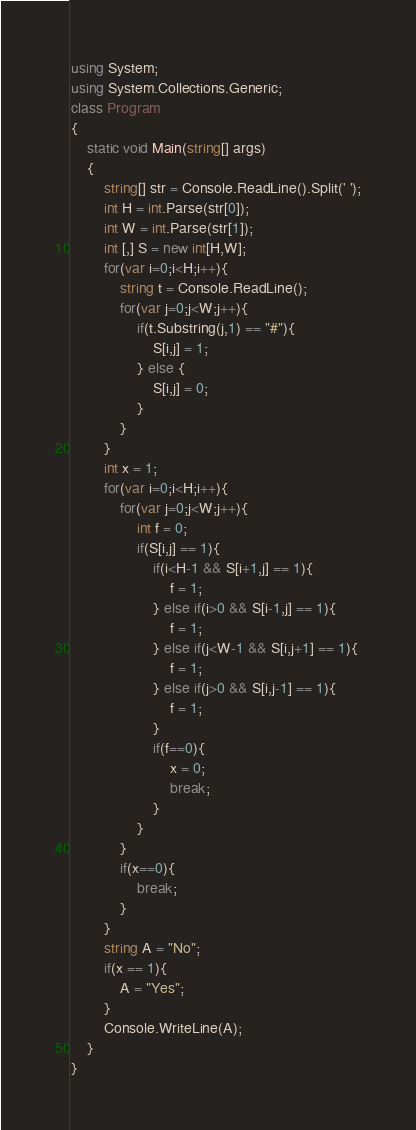<code> <loc_0><loc_0><loc_500><loc_500><_C#_>using System;
using System.Collections.Generic;
class Program
{
	static void Main(string[] args)
	{
		string[] str = Console.ReadLine().Split(' ');
		int H = int.Parse(str[0]);
		int W = int.Parse(str[1]);
		int [,] S = new int[H,W];
		for(var i=0;i<H;i++){
			string t = Console.ReadLine();
			for(var j=0;j<W;j++){
				if(t.Substring(j,1) == "#"){
					S[i,j] = 1;
				} else {
					S[i,j] = 0;
				}
			}
		}
		int x = 1;
		for(var i=0;i<H;i++){
			for(var j=0;j<W;j++){
				int f = 0;
				if(S[i,j] == 1){
					if(i<H-1 && S[i+1,j] == 1){
						f = 1;
					} else if(i>0 && S[i-1,j] == 1){
						f = 1;
					} else if(j<W-1 && S[i,j+1] == 1){
						f = 1;
					} else if(j>0 && S[i,j-1] == 1){
						f = 1;
					}
					if(f==0){
						x = 0;
						break;
					}
				}
			}
			if(x==0){
				break;
			}
		}
		string A = "No";
		if(x == 1){
			A = "Yes";
		}
		Console.WriteLine(A);
	}
}</code> 